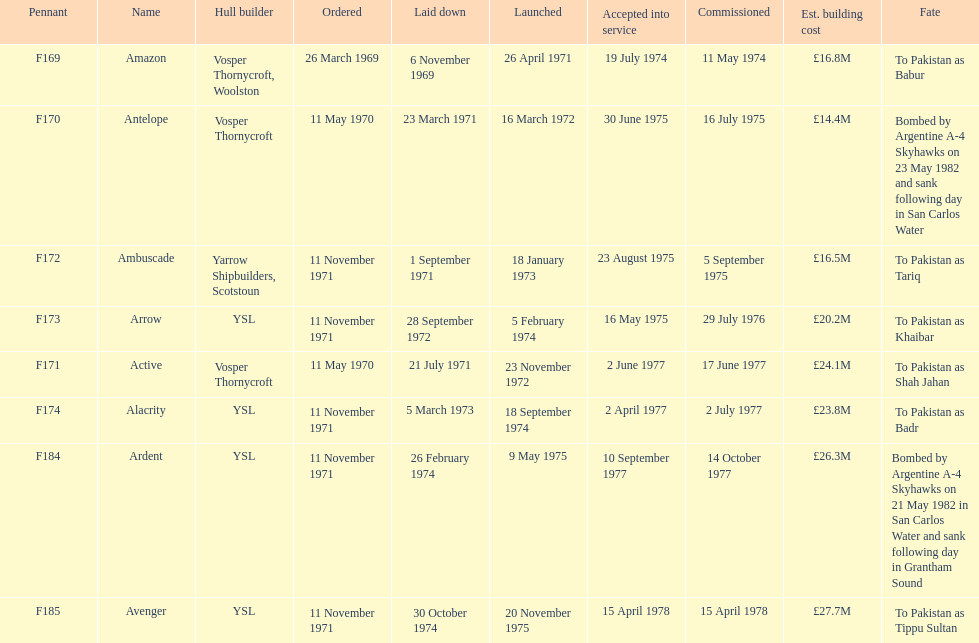Amazon is at the top of the chart, but what is the name below it? Antelope. 